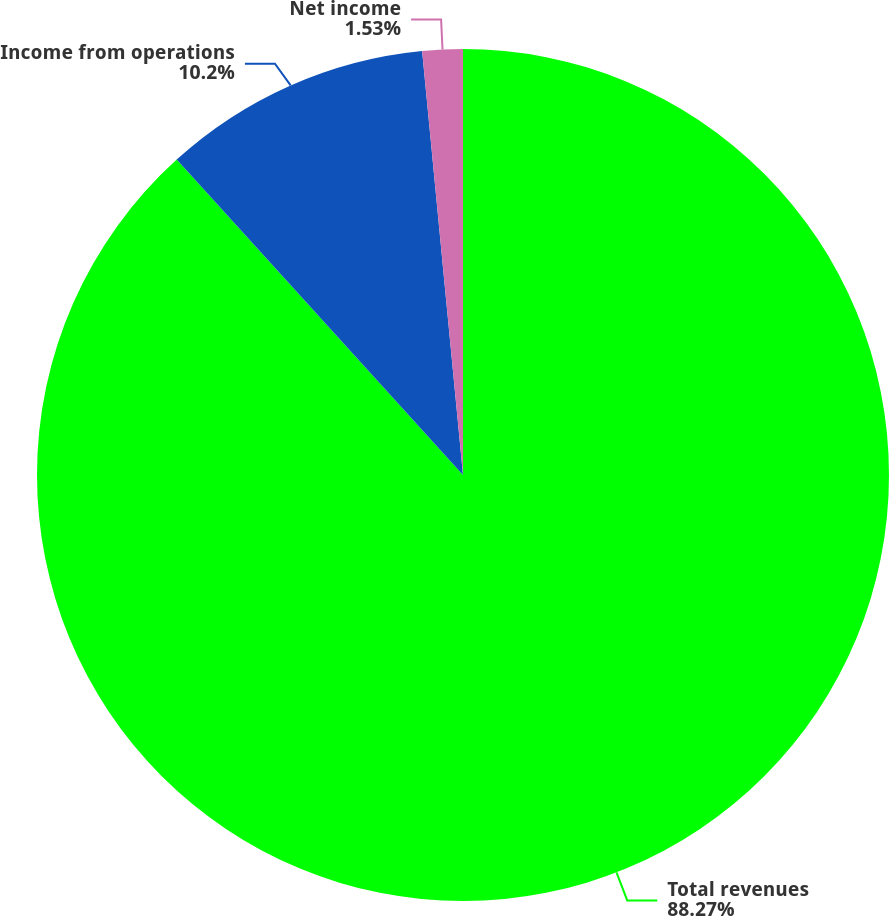<chart> <loc_0><loc_0><loc_500><loc_500><pie_chart><fcel>Total revenues<fcel>Income from operations<fcel>Net income<nl><fcel>88.27%<fcel>10.2%<fcel>1.53%<nl></chart> 